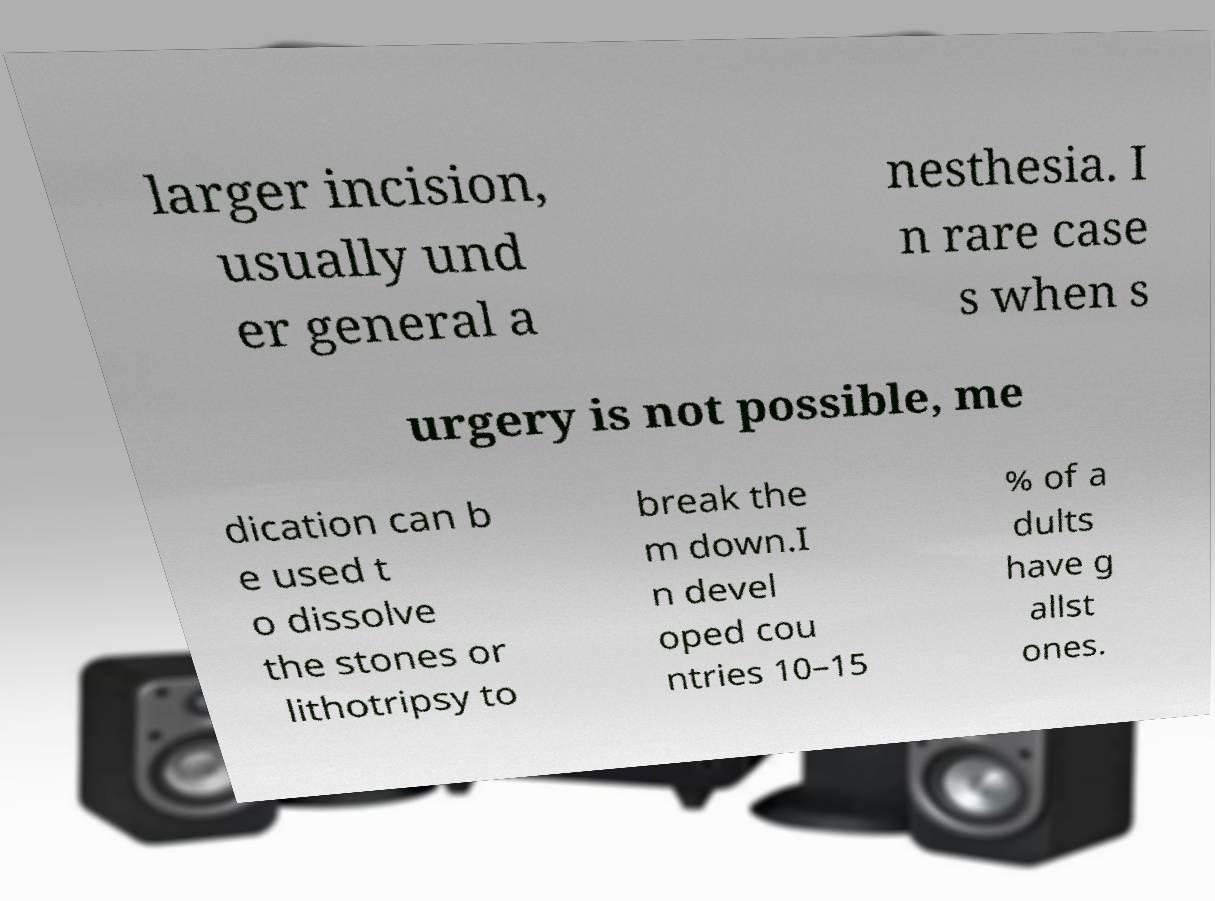For documentation purposes, I need the text within this image transcribed. Could you provide that? larger incision, usually und er general a nesthesia. I n rare case s when s urgery is not possible, me dication can b e used t o dissolve the stones or lithotripsy to break the m down.I n devel oped cou ntries 10–15 % of a dults have g allst ones. 